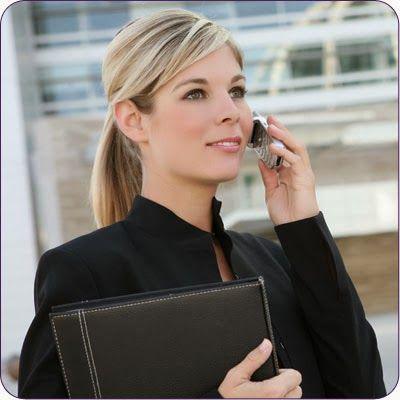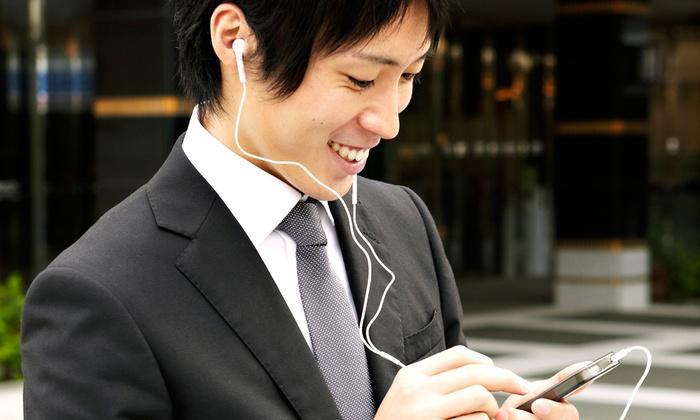The first image is the image on the left, the second image is the image on the right. Examine the images to the left and right. Is the description "There is exactly one person in every photo, and the person on the left is interacting with two phones at once, while the person on the right is showing an emotion and interacting with only one phone." accurate? Answer yes or no. No. The first image is the image on the left, the second image is the image on the right. For the images displayed, is the sentence "One image shows a smiling woman holding a phone to her ear, and the other image features a man in a dark suit with something next to his ear and something held in front of him." factually correct? Answer yes or no. Yes. 